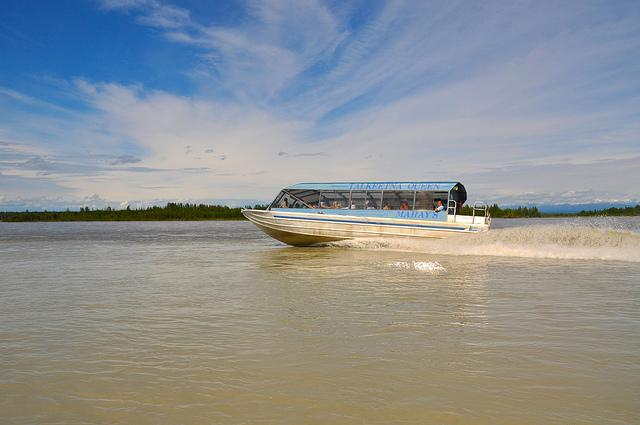What is this watercraft's purpose? Please explain your reasoning. excursions. The boat goes on trips. 